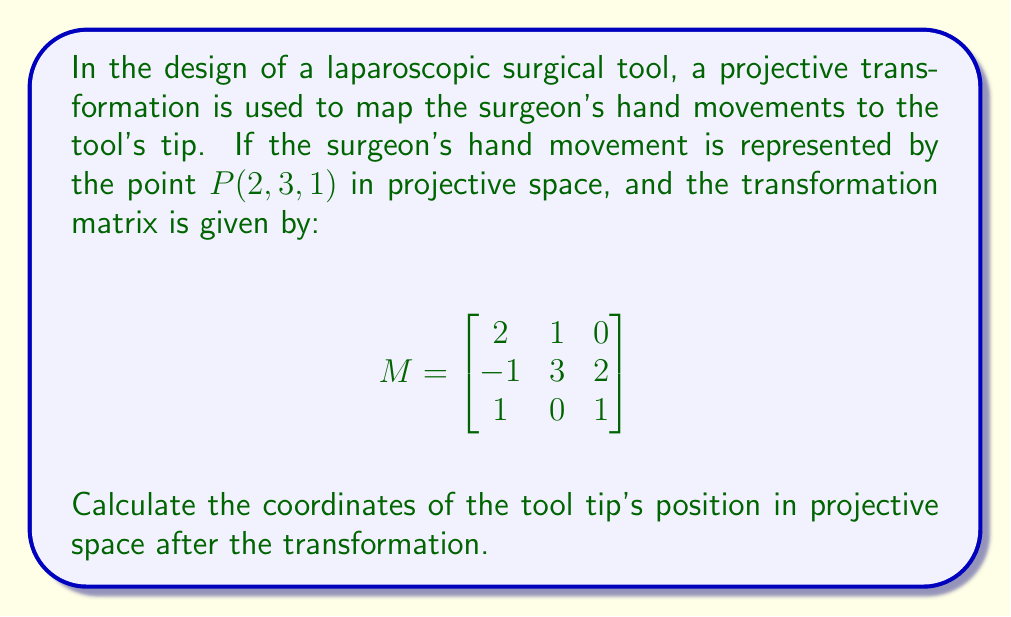Help me with this question. To solve this problem, we need to follow these steps:

1) The projective transformation is given by the matrix multiplication $MP$, where $M$ is the transformation matrix and $P$ is the point representing the surgeon's hand movement.

2) We need to multiply the matrix $M$ by the column vector $P$:

   $$\begin{bmatrix}
   2 & 1 & 0 \\
   -1 & 3 & 2 \\
   1 & 0 & 1
   \end{bmatrix} \begin{bmatrix}
   2 \\
   3 \\
   1
   \end{bmatrix}$$

3) Let's perform the matrix multiplication:

   $$(2 \cdot 2 + 1 \cdot 3 + 0 \cdot 1, -1 \cdot 2 + 3 \cdot 3 + 2 \cdot 1, 1 \cdot 2 + 0 \cdot 3 + 1 \cdot 1)$$

4) Simplifying:

   $$(4 + 3 + 0, -2 + 9 + 2, 2 + 0 + 1)$$

5) This gives us:

   $$(7, 9, 3)$$

6) In projective geometry, we typically normalize the result so that the last coordinate is 1. To do this, we divide all coordinates by the last coordinate:

   $$(\frac{7}{3}, \frac{9}{3}, \frac{3}{3}) = (\frac{7}{3}, 3, 1)$$

Thus, the final position of the tool tip in projective space is $(\frac{7}{3}, 3, 1)$.
Answer: $(\frac{7}{3}, 3, 1)$ 